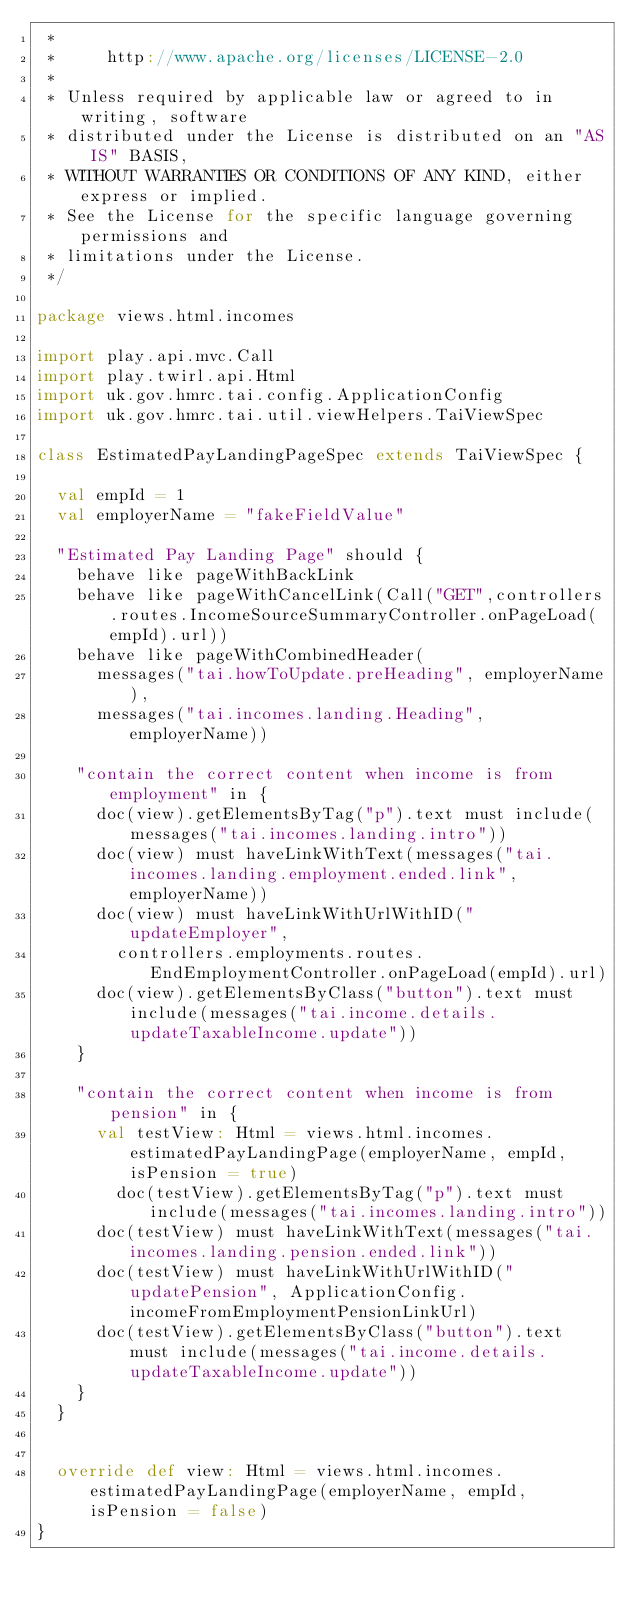<code> <loc_0><loc_0><loc_500><loc_500><_Scala_> *
 *     http://www.apache.org/licenses/LICENSE-2.0
 *
 * Unless required by applicable law or agreed to in writing, software
 * distributed under the License is distributed on an "AS IS" BASIS,
 * WITHOUT WARRANTIES OR CONDITIONS OF ANY KIND, either express or implied.
 * See the License for the specific language governing permissions and
 * limitations under the License.
 */

package views.html.incomes

import play.api.mvc.Call
import play.twirl.api.Html
import uk.gov.hmrc.tai.config.ApplicationConfig
import uk.gov.hmrc.tai.util.viewHelpers.TaiViewSpec

class EstimatedPayLandingPageSpec extends TaiViewSpec {

  val empId = 1
  val employerName = "fakeFieldValue"

  "Estimated Pay Landing Page" should {
    behave like pageWithBackLink
    behave like pageWithCancelLink(Call("GET",controllers.routes.IncomeSourceSummaryController.onPageLoad(empId).url))
    behave like pageWithCombinedHeader(
      messages("tai.howToUpdate.preHeading", employerName),
      messages("tai.incomes.landing.Heading", employerName))

    "contain the correct content when income is from employment" in {
      doc(view).getElementsByTag("p").text must include(messages("tai.incomes.landing.intro"))
      doc(view) must haveLinkWithText(messages("tai.incomes.landing.employment.ended.link", employerName))
      doc(view) must haveLinkWithUrlWithID("updateEmployer",
        controllers.employments.routes.EndEmploymentController.onPageLoad(empId).url)
      doc(view).getElementsByClass("button").text must include(messages("tai.income.details.updateTaxableIncome.update"))
    }

    "contain the correct content when income is from pension" in {
      val testView: Html = views.html.incomes.estimatedPayLandingPage(employerName, empId, isPension = true)
        doc(testView).getElementsByTag("p").text must include(messages("tai.incomes.landing.intro"))
      doc(testView) must haveLinkWithText(messages("tai.incomes.landing.pension.ended.link"))
      doc(testView) must haveLinkWithUrlWithID("updatePension", ApplicationConfig.incomeFromEmploymentPensionLinkUrl)
      doc(testView).getElementsByClass("button").text must include(messages("tai.income.details.updateTaxableIncome.update"))
    }
  }


  override def view: Html = views.html.incomes.estimatedPayLandingPage(employerName, empId, isPension = false)
}
</code> 